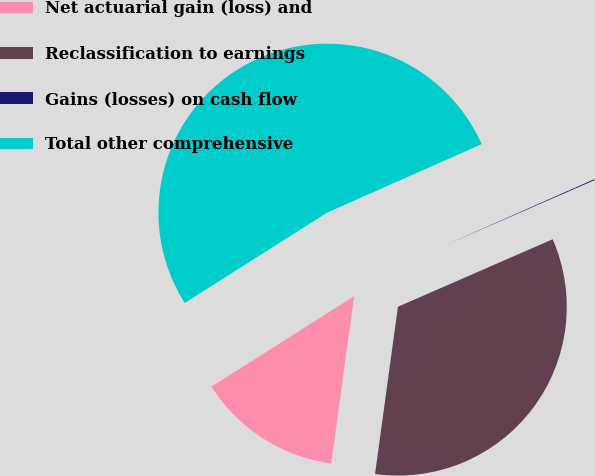Convert chart to OTSL. <chart><loc_0><loc_0><loc_500><loc_500><pie_chart><fcel>Net actuarial gain (loss) and<fcel>Reclassification to earnings<fcel>Gains (losses) on cash flow<fcel>Total other comprehensive<nl><fcel>13.84%<fcel>33.71%<fcel>0.09%<fcel>52.36%<nl></chart> 